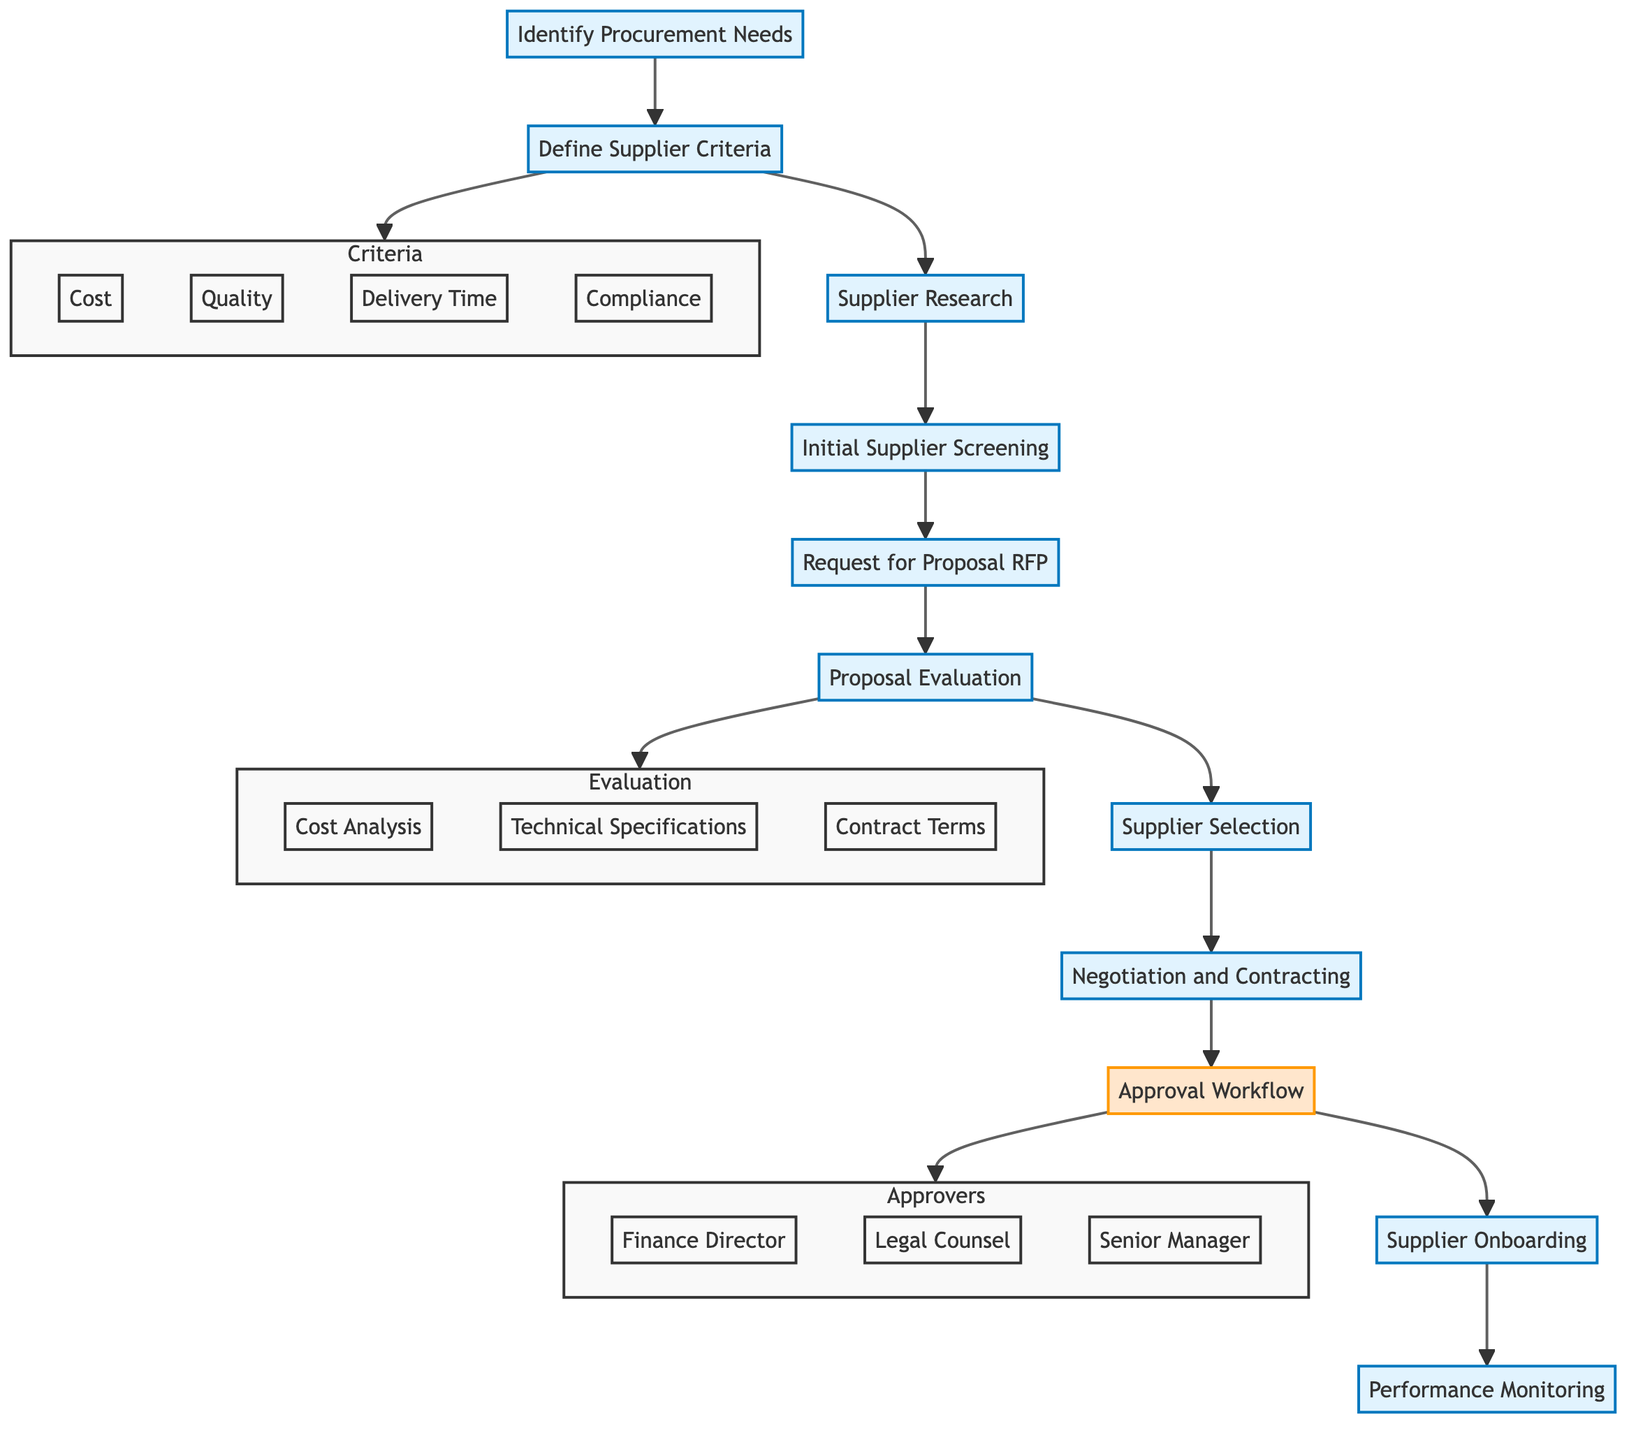What is the first stage in the flow chart? The flow chart begins with the stage "Identify Procurement Needs" as the first step in the supplier selection process.
Answer: Identify Procurement Needs How many stages are there in the flow chart? The flow chart contains a total of 11 stages, including both main stages and subgraphs such as "Evaluation" and "Approvers."
Answer: 11 Which team is responsible for the initial supplier screening? The Logistics Manager is specifically mentioned as the responsible party for the "Initial Supplier Screening" stage in the flow chart.
Answer: Logistics Manager What tools are used in the 'Initial Supplier Screening' stage? This stage uses tools such as "RFI (Request for Information)" and "Supplier Rating Tools" for effectively assessing suppliers during the initial screening.
Answer: RFI, Supplier Rating Tools What stage follows 'Negotiation and Contracting'? Following the stage of "Negotiation and Contracting," the next stage in the flow is "Approval Workflow," which involves obtaining necessary approvals before moving forward.
Answer: Approval Workflow Which criteria are established in the 'Define Supplier Criteria' stage? In this stage, criteria such as "Cost," "Quality," "Delivery Time," and "Compliance" are defined, which will guide the supplier evaluation process.
Answer: Cost, Quality, Delivery Time, Compliance Who needs to approve the workflow according to the flow chart? The "Approval Workflow" stage requires approvals from three key positions: "Finance Director," "Legal Counsel," and "Senior Manager."
Answer: Finance Director, Legal Counsel, Senior Manager What is the last stage in the supplier selection flow? The final stage in the flow chart is "Performance Monitoring," where the suppliers' performance is regularly assessed based on established KPIs.
Answer: Performance Monitoring What documents are involved in the 'Negotiation and Contracting' stage? The documents required during this stage include a "Contract Draft" and a "NDA (Non-Disclosure Agreement)," which are crucial for formalizing the agreement with the selected supplier.
Answer: Contract Draft, NDA What is the purpose of the 'Supplier Onboarding' stage? This stage is designed to complete the onboarding process, which includes activities like "System Integration," "Supplier Training," and "Compliance Checks" to ensure effective collaboration.
Answer: Complete onboarding process 